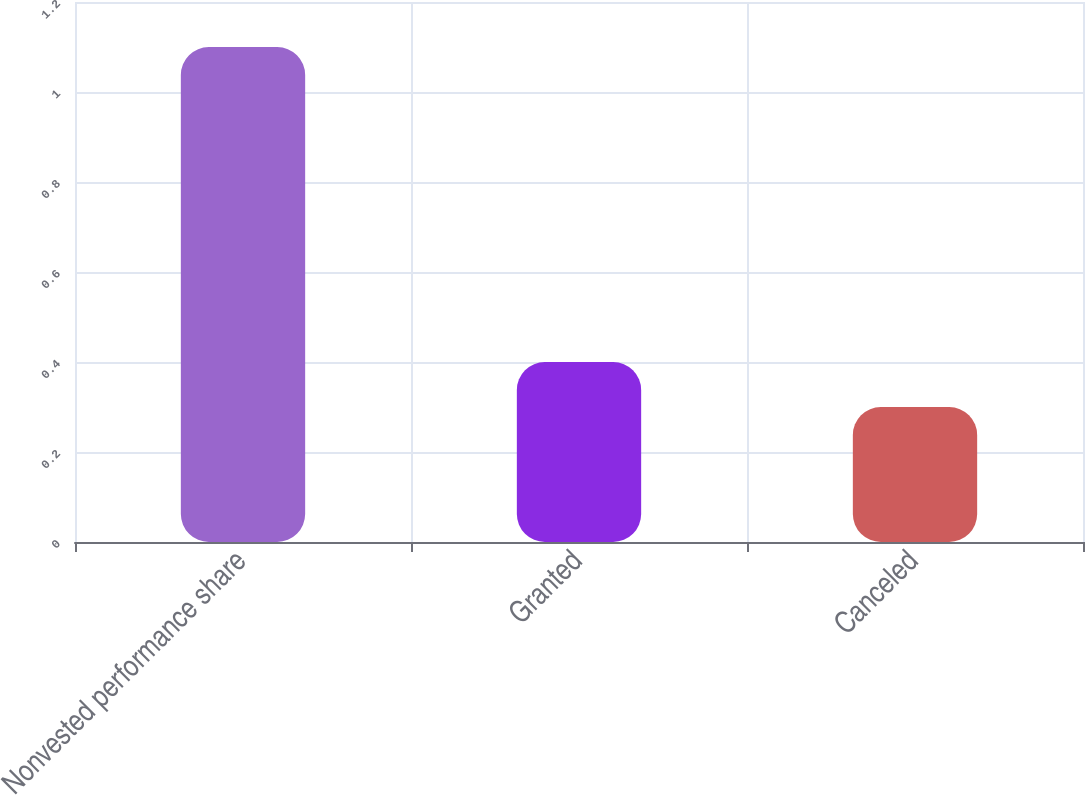<chart> <loc_0><loc_0><loc_500><loc_500><bar_chart><fcel>Nonvested performance share<fcel>Granted<fcel>Canceled<nl><fcel>1.1<fcel>0.4<fcel>0.3<nl></chart> 